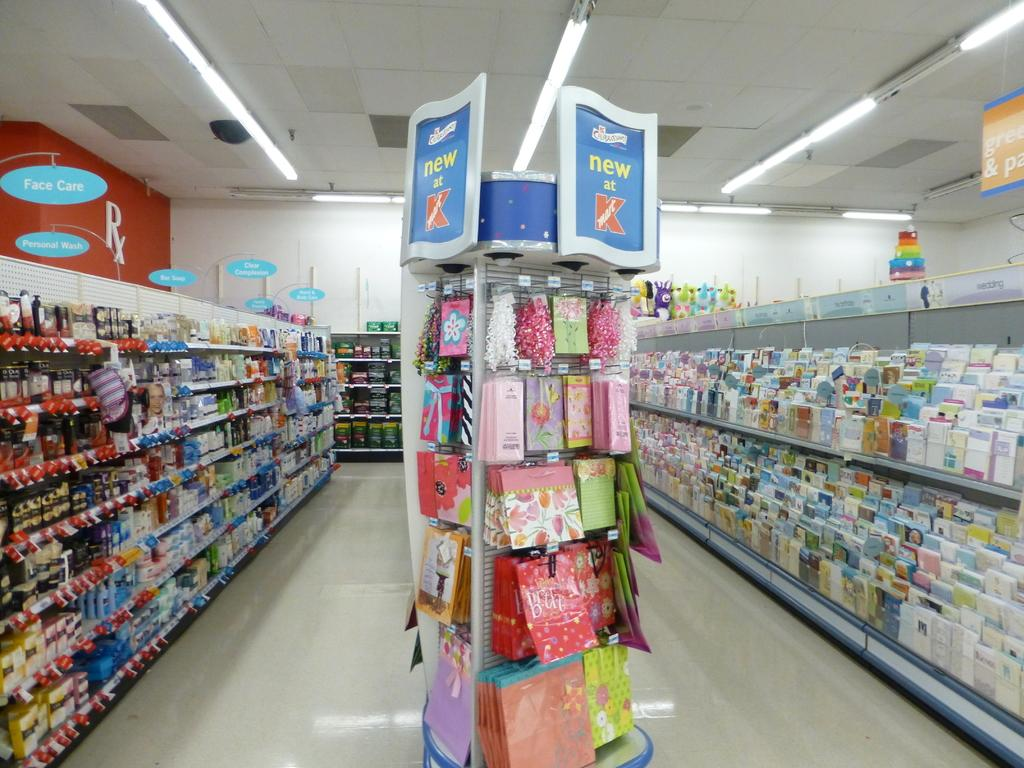Provide a one-sentence caption for the provided image. A sign at the end of the aisle advertises what is new at Kmart. 